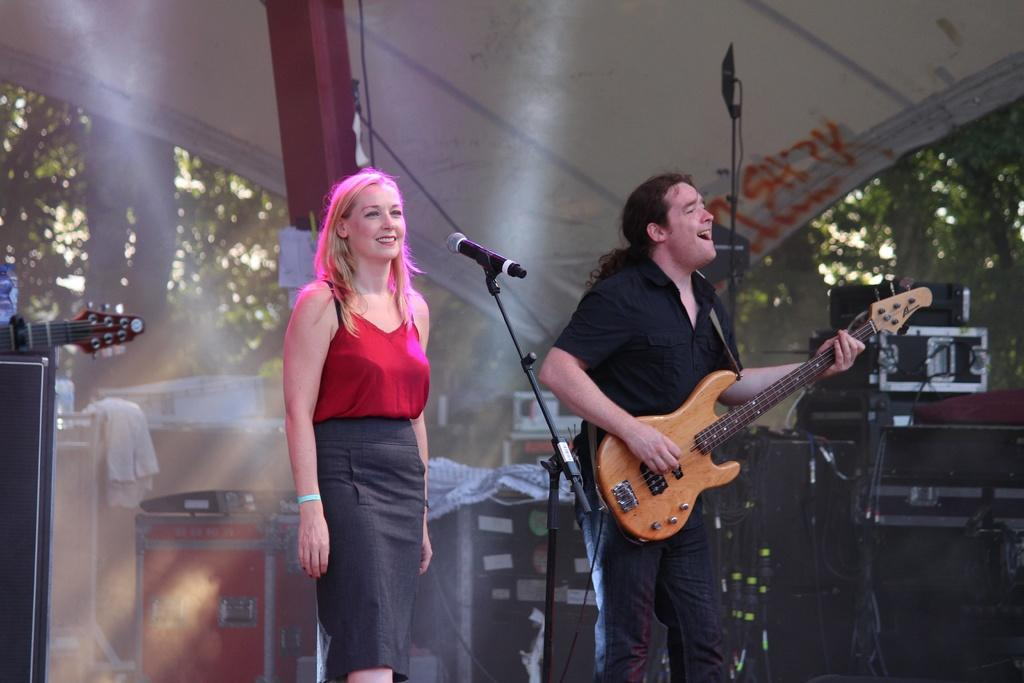What is the man in the image doing? The man is standing in front of a microphone, playing a guitar, and singing. Can you describe the woman in the image? The woman is standing in front of a microphone and smiling. What are the two individuals in the image doing together? They are both standing in front of microphones, suggesting they might be performing together. What type of drain can be seen in the image? There is no drain present in the image. Can you describe the trail that the man is walking on in the image? There is no trail or walking depicted in the image; the man is standing in front of a microphone. 